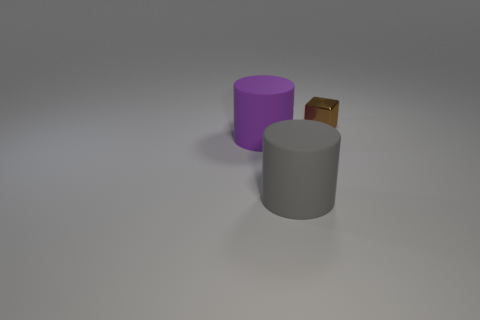Are there fewer gray cylinders than small balls?
Your answer should be very brief. No. There is a rubber object left of the big rubber cylinder on the right side of the big purple matte thing; what is its shape?
Provide a succinct answer. Cylinder. Is there anything else that is the same size as the gray object?
Your response must be concise. Yes. What is the shape of the metallic object right of the large rubber thing that is to the right of the large cylinder to the left of the big gray cylinder?
Ensure brevity in your answer.  Cube. What number of objects are either purple rubber cylinders behind the gray rubber cylinder or things that are in front of the shiny object?
Keep it short and to the point. 2. Is the size of the brown metal block the same as the matte cylinder that is behind the large gray object?
Your answer should be very brief. No. Does the thing that is on the left side of the gray cylinder have the same material as the cylinder that is right of the purple cylinder?
Ensure brevity in your answer.  Yes. Is the number of tiny things behind the brown block the same as the number of large rubber objects in front of the purple matte cylinder?
Your answer should be very brief. No. How many large rubber cylinders are the same color as the tiny shiny object?
Offer a terse response. 0. How many shiny objects are either blocks or cylinders?
Provide a succinct answer. 1. 